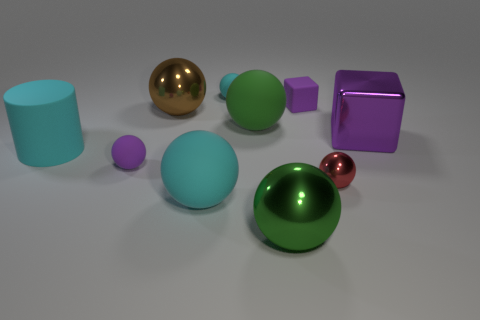Subtract all cyan balls. How many balls are left? 5 Subtract all tiny purple matte spheres. How many spheres are left? 6 Subtract 3 spheres. How many spheres are left? 4 Subtract all blue spheres. Subtract all purple cubes. How many spheres are left? 7 Subtract all cylinders. How many objects are left? 9 Add 8 small metal balls. How many small metal balls exist? 9 Subtract 0 red blocks. How many objects are left? 10 Subtract all tiny green balls. Subtract all large brown objects. How many objects are left? 9 Add 7 purple shiny objects. How many purple shiny objects are left? 8 